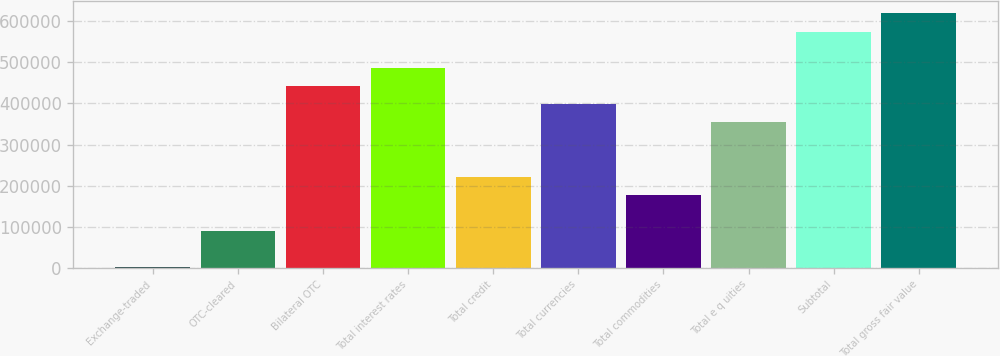Convert chart to OTSL. <chart><loc_0><loc_0><loc_500><loc_500><bar_chart><fcel>Exchange-traded<fcel>OTC-cleared<fcel>Bilateral OTC<fcel>Total interest rates<fcel>Total credit<fcel>Total currencies<fcel>Total commodities<fcel>Total e q uities<fcel>Subtotal<fcel>Total gross fair value<nl><fcel>644<fcel>89046.6<fcel>442657<fcel>486858<fcel>221650<fcel>398456<fcel>177449<fcel>354254<fcel>575261<fcel>619462<nl></chart> 